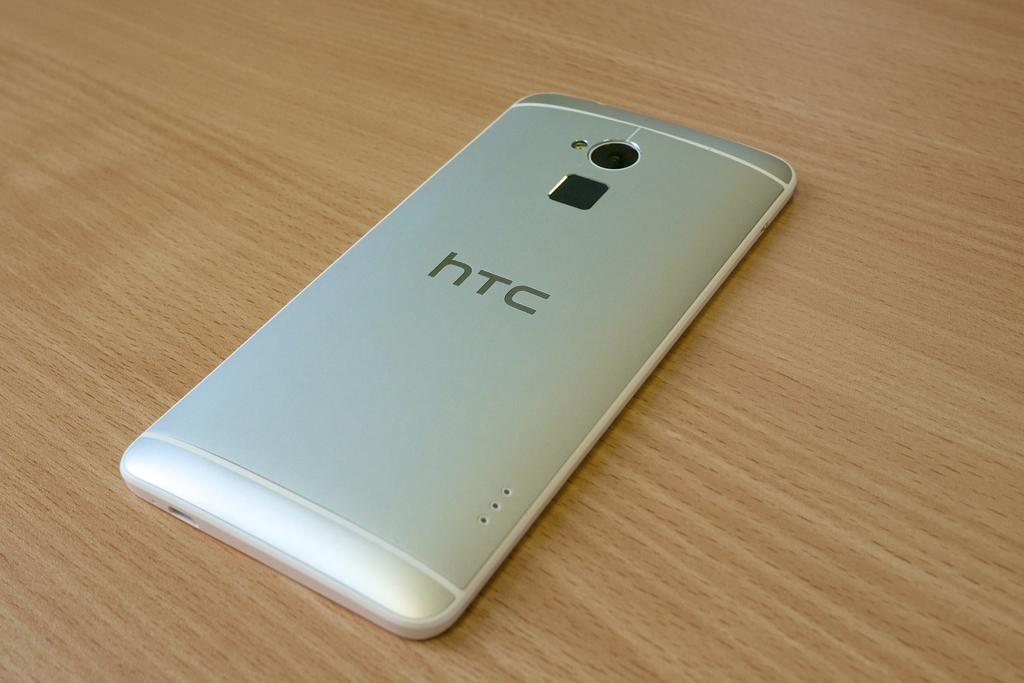<image>
Summarize the visual content of the image. The HTC phone is laying face down on the table. 